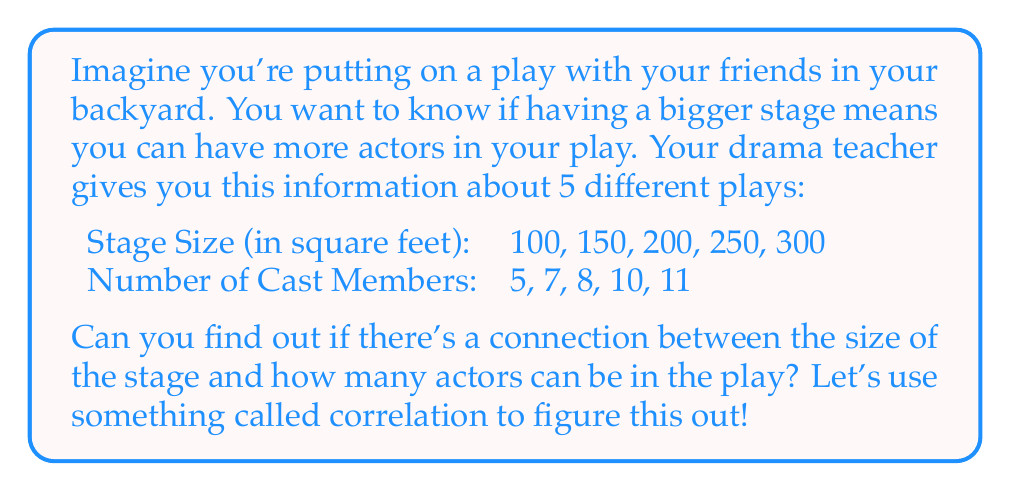What is the answer to this math problem? To find out if there's a relationship between stage size and the number of cast members, we can calculate something called the correlation coefficient. This is a number that tells us how closely these two things are related. Here's how we can do it:

1. First, we need to calculate the mean (average) of both the stage sizes and the number of cast members:

   Mean of stage sizes: $\bar{x} = \frac{100 + 150 + 200 + 250 + 300}{5} = 200$
   Mean of cast members: $\bar{y} = \frac{5 + 7 + 8 + 10 + 11}{5} = 8.2$

2. Now, we need to calculate the differences from the mean for each value:

   For stage sizes: 
   $100 - 200 = -100$, $150 - 200 = -50$, $200 - 200 = 0$, $250 - 200 = 50$, $300 - 200 = 100$

   For cast members:
   $5 - 8.2 = -3.2$, $7 - 8.2 = -1.2$, $8 - 8.2 = -0.2$, $10 - 8.2 = 1.8$, $11 - 8.2 = 2.8$

3. Next, we multiply these differences together for each pair:

   $(-100)(-3.2) = 320$, $(-50)(-1.2) = 60$, $(0)(-0.2) = 0$, $(50)(1.8) = 90$, $(100)(2.8) = 280$

4. We add up all these products:

   $320 + 60 + 0 + 90 + 280 = 750$

5. Now we need to calculate the sum of the squared differences for each variable:

   For stage sizes: $(-100)^2 + (-50)^2 + 0^2 + 50^2 + 100^2 = 30,000$
   For cast members: $(-3.2)^2 + (-1.2)^2 + (-0.2)^2 + 1.8^2 + 2.8^2 = 24.8$

6. We multiply these sums:

   $30,000 * 24.8 = 744,000$

7. We take the square root of this product:

   $\sqrt{744,000} = 862.55$

8. Finally, we divide the sum from step 4 by this square root:

   $\frac{750}{862.55} = 0.87$

This number (0.87) is called the correlation coefficient. It's always between -1 and 1. When it's close to 1, like in this case, it means there's a strong positive relationship between the two things we're looking at.
Answer: The correlation coefficient is approximately 0.87, indicating a strong positive relationship between stage size and the number of cast members. This means that as the stage size increases, the number of cast members tends to increase as well. 